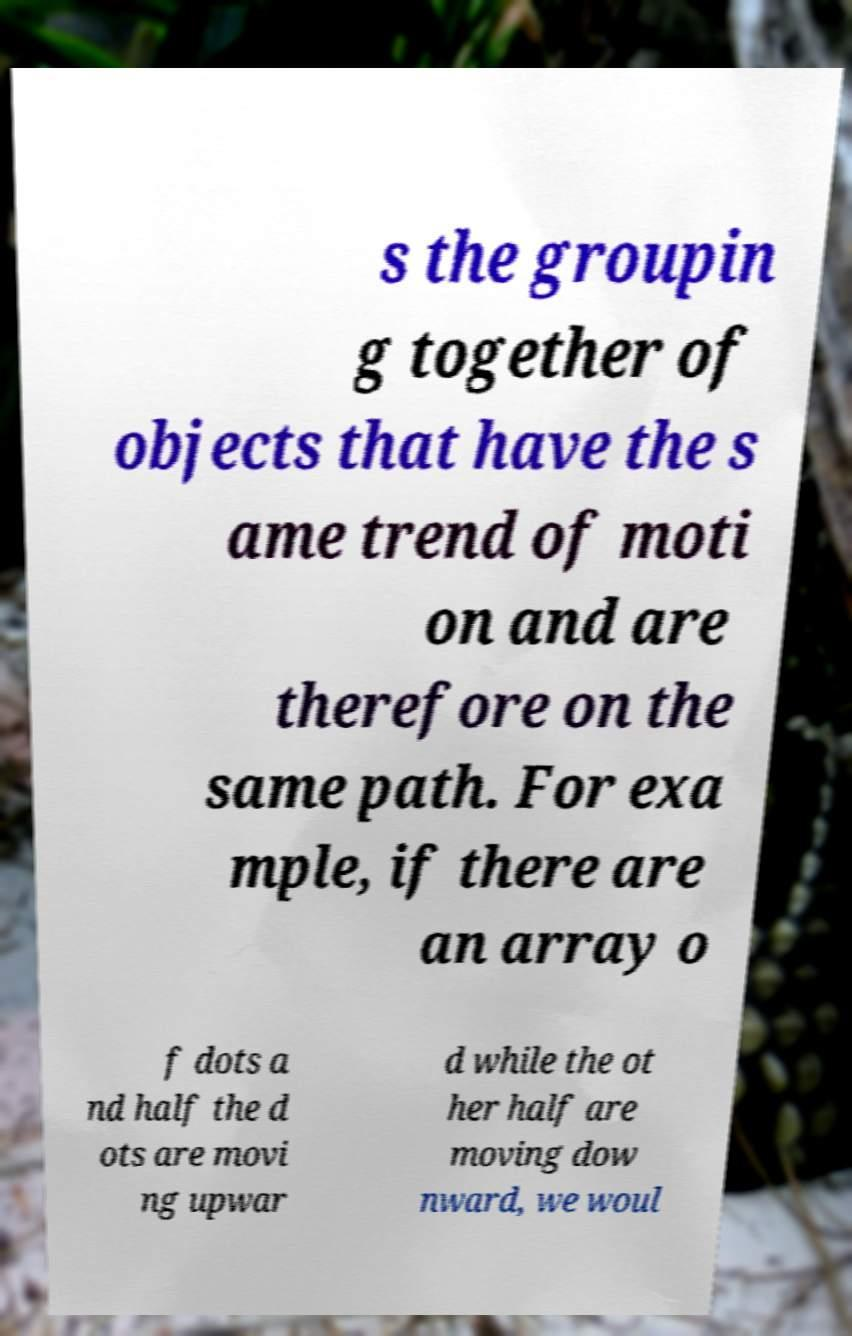What messages or text are displayed in this image? I need them in a readable, typed format. s the groupin g together of objects that have the s ame trend of moti on and are therefore on the same path. For exa mple, if there are an array o f dots a nd half the d ots are movi ng upwar d while the ot her half are moving dow nward, we woul 